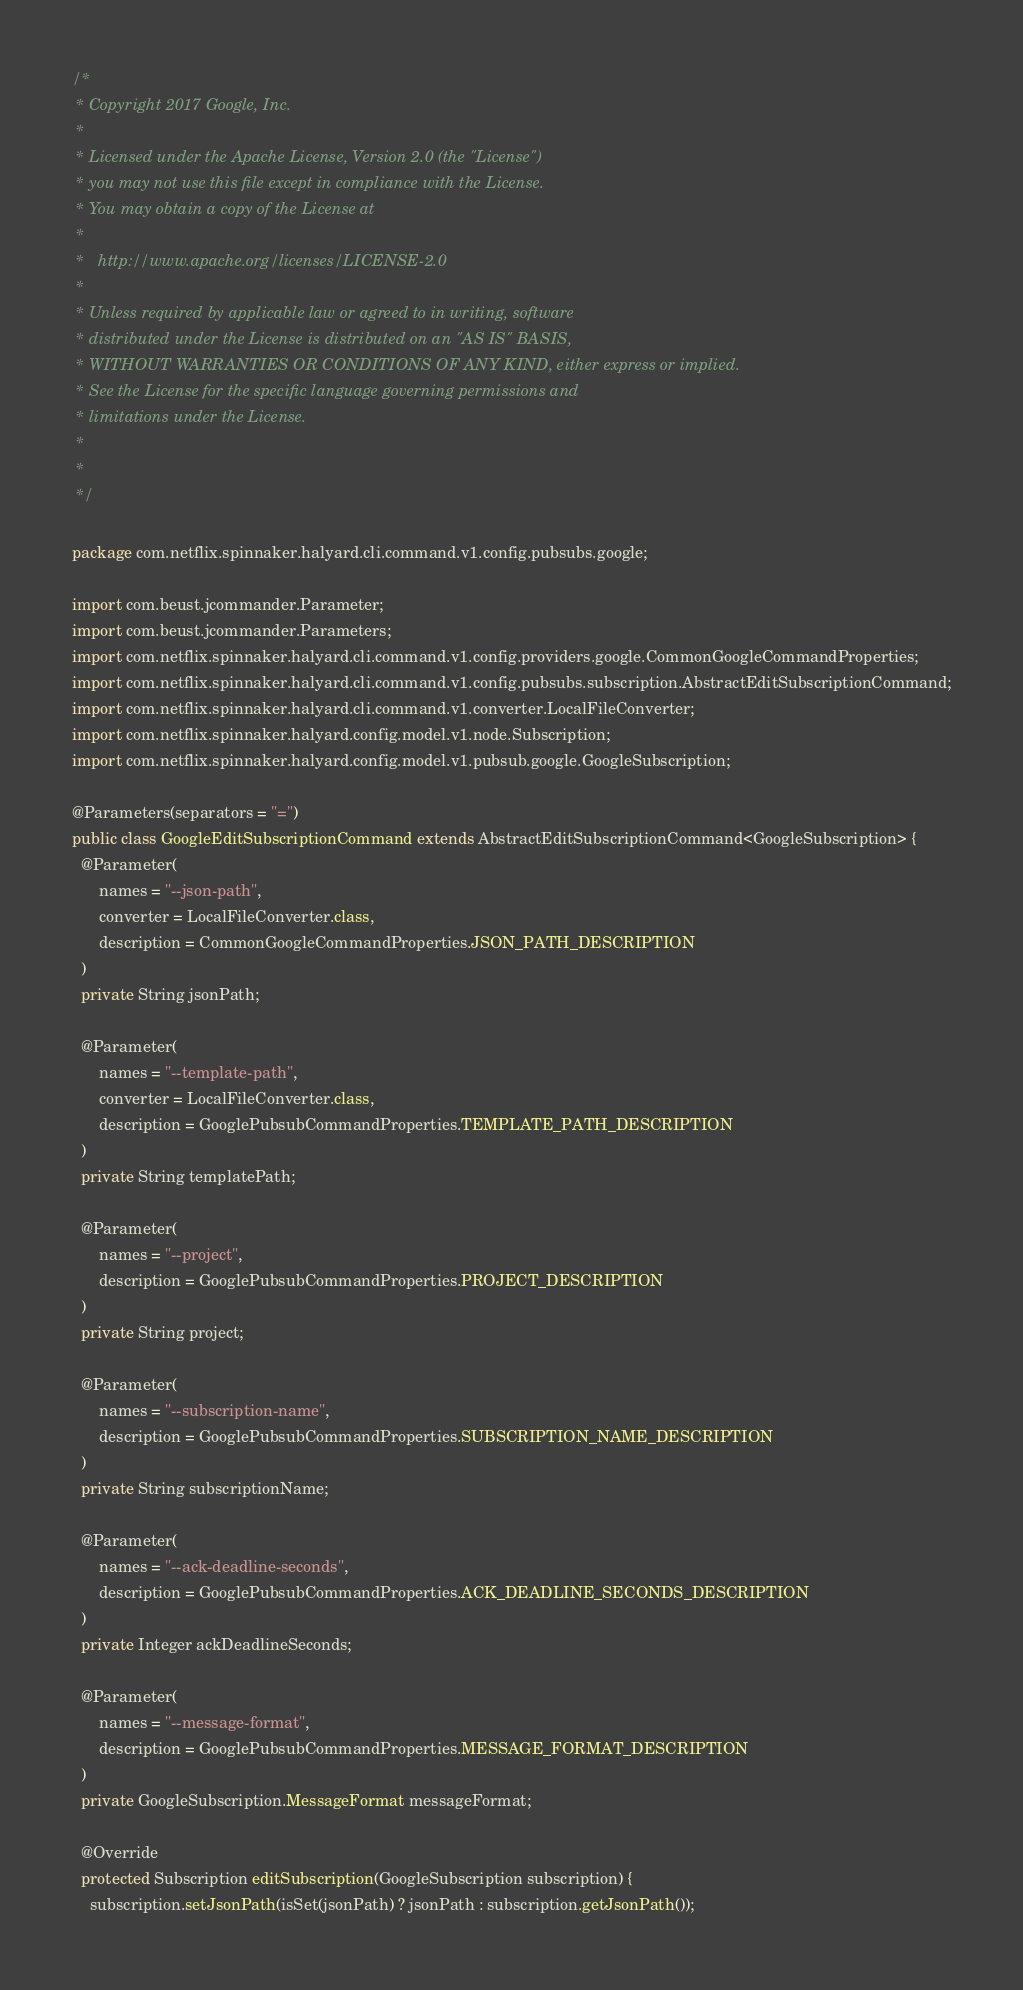<code> <loc_0><loc_0><loc_500><loc_500><_Java_>/*
 * Copyright 2017 Google, Inc.
 *
 * Licensed under the Apache License, Version 2.0 (the "License")
 * you may not use this file except in compliance with the License.
 * You may obtain a copy of the License at
 *
 *   http://www.apache.org/licenses/LICENSE-2.0
 *
 * Unless required by applicable law or agreed to in writing, software
 * distributed under the License is distributed on an "AS IS" BASIS,
 * WITHOUT WARRANTIES OR CONDITIONS OF ANY KIND, either express or implied.
 * See the License for the specific language governing permissions and
 * limitations under the License.
 *
 *
 */

package com.netflix.spinnaker.halyard.cli.command.v1.config.pubsubs.google;

import com.beust.jcommander.Parameter;
import com.beust.jcommander.Parameters;
import com.netflix.spinnaker.halyard.cli.command.v1.config.providers.google.CommonGoogleCommandProperties;
import com.netflix.spinnaker.halyard.cli.command.v1.config.pubsubs.subscription.AbstractEditSubscriptionCommand;
import com.netflix.spinnaker.halyard.cli.command.v1.converter.LocalFileConverter;
import com.netflix.spinnaker.halyard.config.model.v1.node.Subscription;
import com.netflix.spinnaker.halyard.config.model.v1.pubsub.google.GoogleSubscription;

@Parameters(separators = "=")
public class GoogleEditSubscriptionCommand extends AbstractEditSubscriptionCommand<GoogleSubscription> {
  @Parameter(
      names = "--json-path",
      converter = LocalFileConverter.class,
      description = CommonGoogleCommandProperties.JSON_PATH_DESCRIPTION
  )
  private String jsonPath;

  @Parameter(
      names = "--template-path",
      converter = LocalFileConverter.class,
      description = GooglePubsubCommandProperties.TEMPLATE_PATH_DESCRIPTION
  )
  private String templatePath;

  @Parameter(
      names = "--project",
      description = GooglePubsubCommandProperties.PROJECT_DESCRIPTION
  )
  private String project;

  @Parameter(
      names = "--subscription-name",
      description = GooglePubsubCommandProperties.SUBSCRIPTION_NAME_DESCRIPTION
  )
  private String subscriptionName;

  @Parameter(
      names = "--ack-deadline-seconds",
      description = GooglePubsubCommandProperties.ACK_DEADLINE_SECONDS_DESCRIPTION
  )
  private Integer ackDeadlineSeconds;

  @Parameter(
      names = "--message-format",
      description = GooglePubsubCommandProperties.MESSAGE_FORMAT_DESCRIPTION
  )
  private GoogleSubscription.MessageFormat messageFormat;

  @Override
  protected Subscription editSubscription(GoogleSubscription subscription) {
    subscription.setJsonPath(isSet(jsonPath) ? jsonPath : subscription.getJsonPath());</code> 